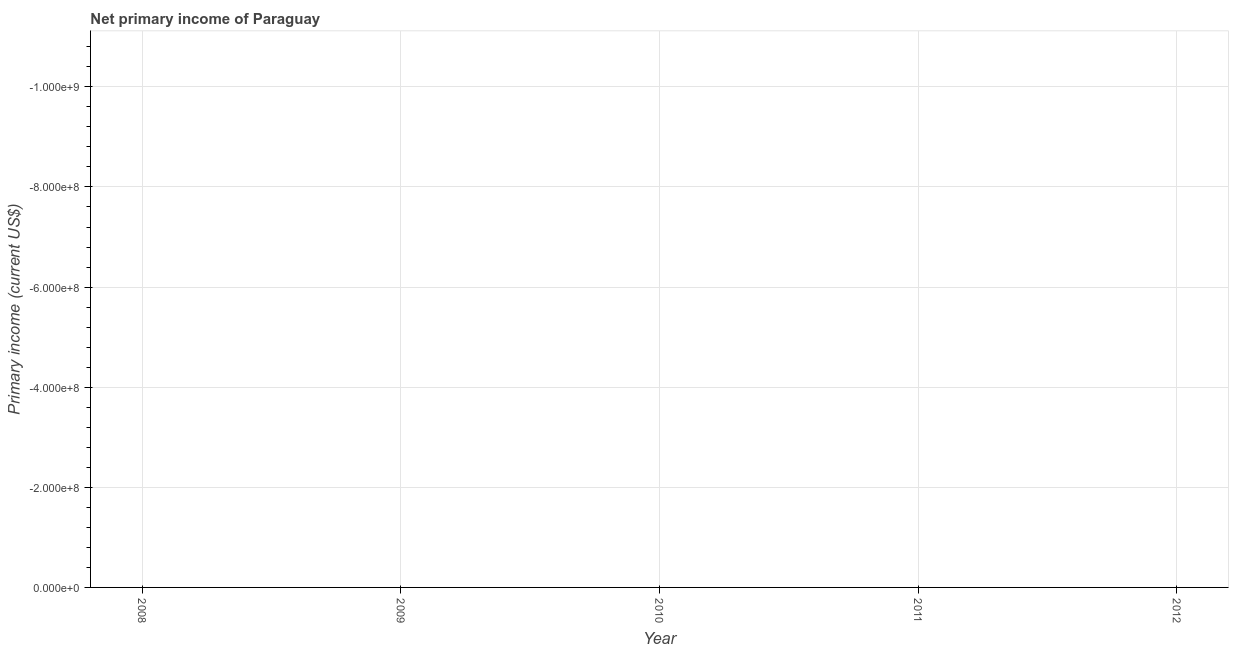What is the amount of primary income in 2012?
Your answer should be very brief. 0. Across all years, what is the minimum amount of primary income?
Provide a succinct answer. 0. In how many years, is the amount of primary income greater than -320000000 US$?
Offer a very short reply. 0. In how many years, is the amount of primary income greater than the average amount of primary income taken over all years?
Keep it short and to the point. 0. Does the amount of primary income monotonically increase over the years?
Your answer should be compact. No. How many dotlines are there?
Your answer should be very brief. 0. How many years are there in the graph?
Provide a short and direct response. 5. What is the title of the graph?
Your answer should be compact. Net primary income of Paraguay. What is the label or title of the Y-axis?
Your answer should be compact. Primary income (current US$). What is the Primary income (current US$) in 2008?
Ensure brevity in your answer.  0. What is the Primary income (current US$) in 2010?
Provide a short and direct response. 0. What is the Primary income (current US$) in 2011?
Ensure brevity in your answer.  0. What is the Primary income (current US$) in 2012?
Keep it short and to the point. 0. 